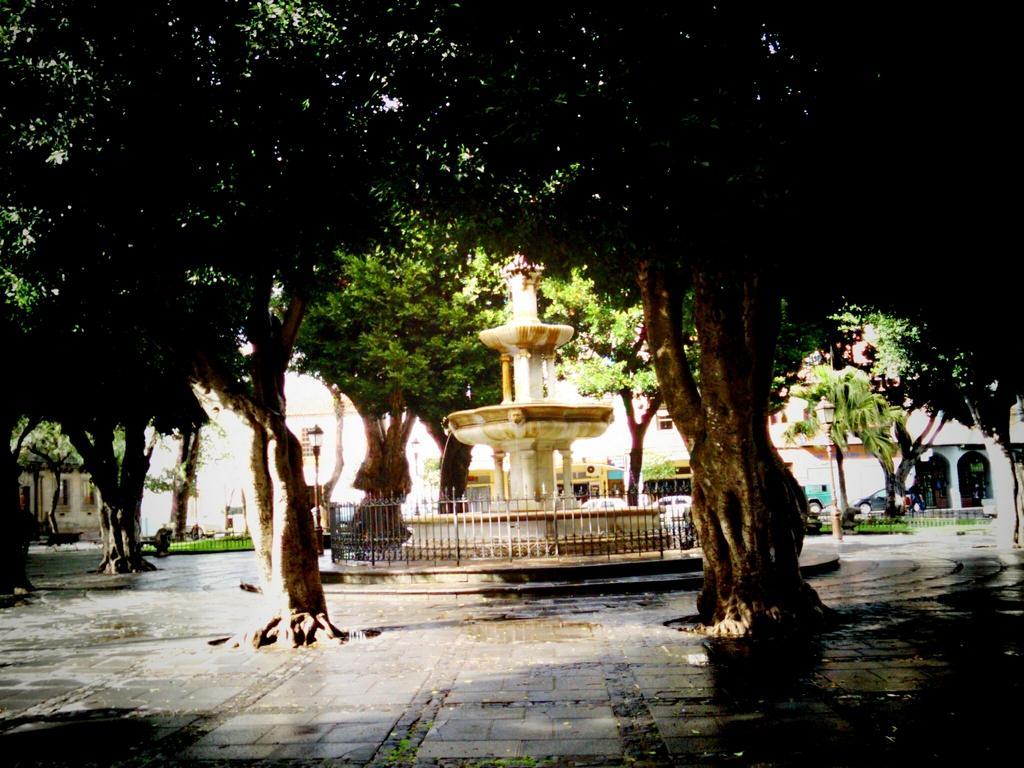Please provide a concise description of this image. In the middle of this image there is a fountain. Around there are many trees. In the background there is a building and I can see few vehicles. 